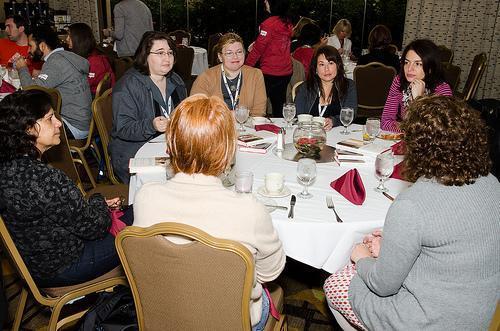How many people are at the table?
Give a very brief answer. 7. 